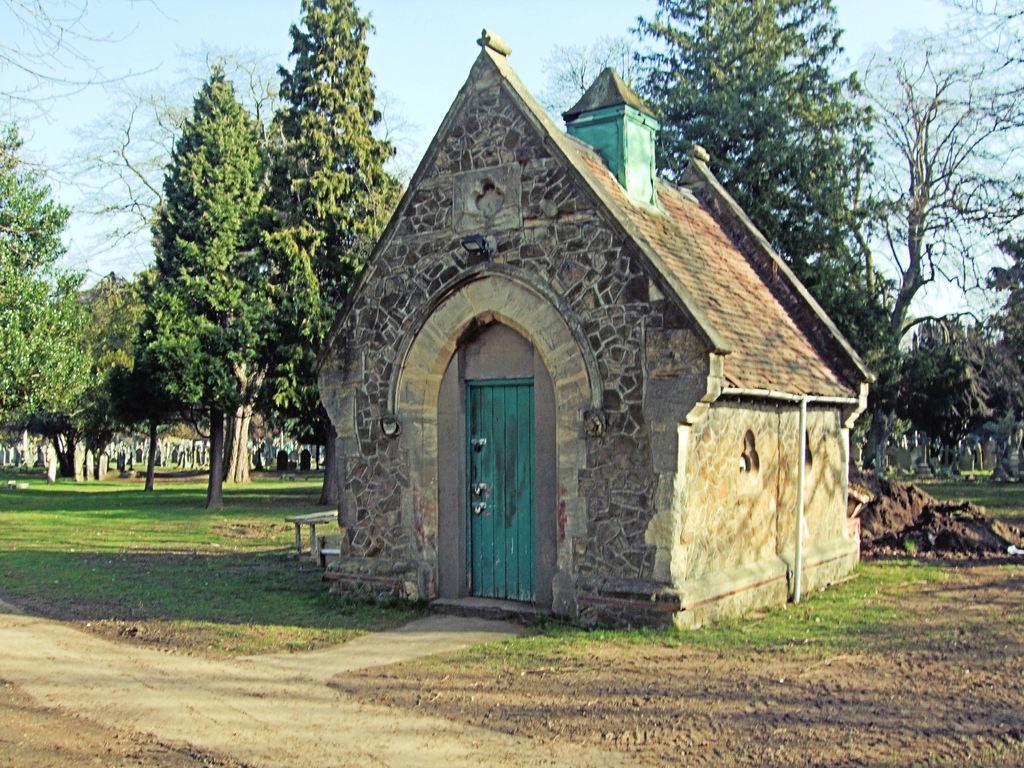How would you summarize this image in a sentence or two? In this image there is a stone house in the middle. In the background there are trees. At the top there is the sky. On the ground there is grass and soil. In the middle there is a door. 